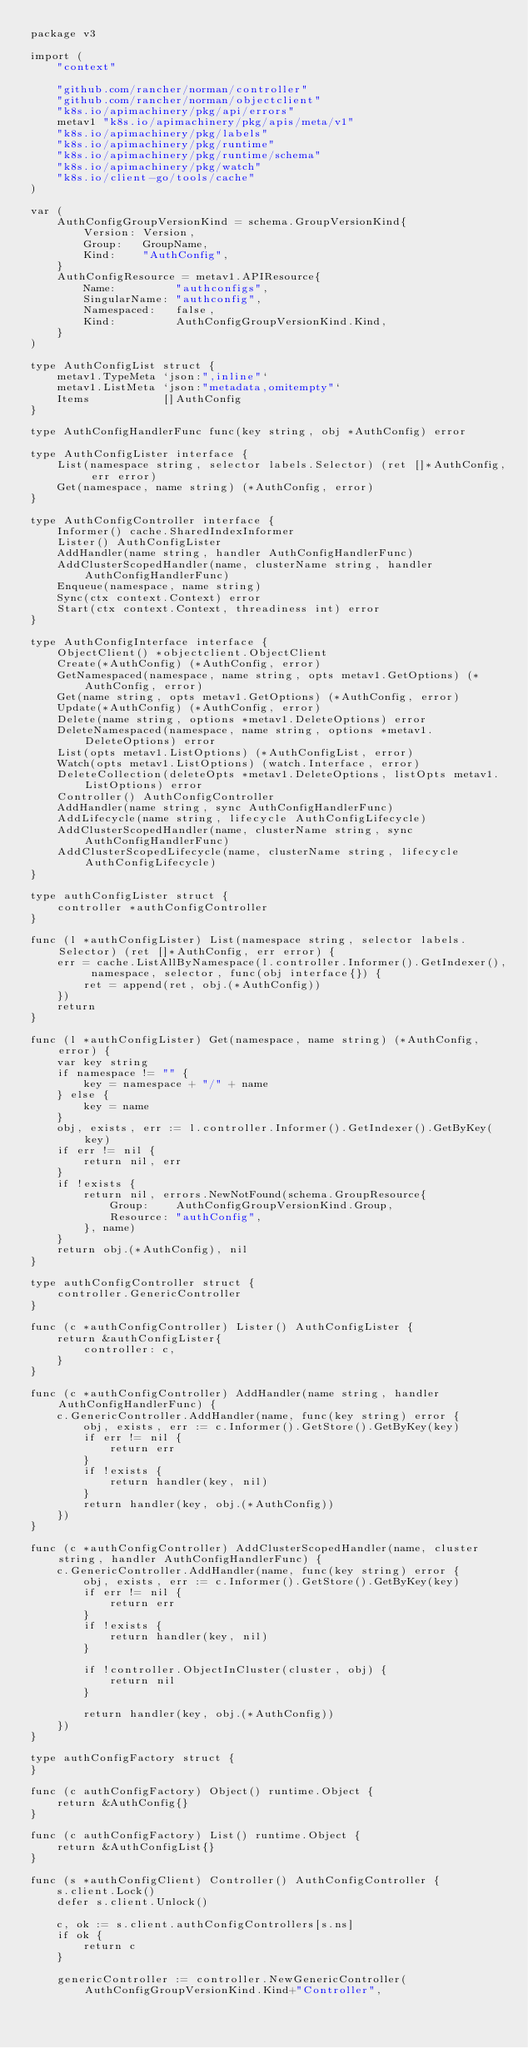Convert code to text. <code><loc_0><loc_0><loc_500><loc_500><_Go_>package v3

import (
	"context"

	"github.com/rancher/norman/controller"
	"github.com/rancher/norman/objectclient"
	"k8s.io/apimachinery/pkg/api/errors"
	metav1 "k8s.io/apimachinery/pkg/apis/meta/v1"
	"k8s.io/apimachinery/pkg/labels"
	"k8s.io/apimachinery/pkg/runtime"
	"k8s.io/apimachinery/pkg/runtime/schema"
	"k8s.io/apimachinery/pkg/watch"
	"k8s.io/client-go/tools/cache"
)

var (
	AuthConfigGroupVersionKind = schema.GroupVersionKind{
		Version: Version,
		Group:   GroupName,
		Kind:    "AuthConfig",
	}
	AuthConfigResource = metav1.APIResource{
		Name:         "authconfigs",
		SingularName: "authconfig",
		Namespaced:   false,
		Kind:         AuthConfigGroupVersionKind.Kind,
	}
)

type AuthConfigList struct {
	metav1.TypeMeta `json:",inline"`
	metav1.ListMeta `json:"metadata,omitempty"`
	Items           []AuthConfig
}

type AuthConfigHandlerFunc func(key string, obj *AuthConfig) error

type AuthConfigLister interface {
	List(namespace string, selector labels.Selector) (ret []*AuthConfig, err error)
	Get(namespace, name string) (*AuthConfig, error)
}

type AuthConfigController interface {
	Informer() cache.SharedIndexInformer
	Lister() AuthConfigLister
	AddHandler(name string, handler AuthConfigHandlerFunc)
	AddClusterScopedHandler(name, clusterName string, handler AuthConfigHandlerFunc)
	Enqueue(namespace, name string)
	Sync(ctx context.Context) error
	Start(ctx context.Context, threadiness int) error
}

type AuthConfigInterface interface {
	ObjectClient() *objectclient.ObjectClient
	Create(*AuthConfig) (*AuthConfig, error)
	GetNamespaced(namespace, name string, opts metav1.GetOptions) (*AuthConfig, error)
	Get(name string, opts metav1.GetOptions) (*AuthConfig, error)
	Update(*AuthConfig) (*AuthConfig, error)
	Delete(name string, options *metav1.DeleteOptions) error
	DeleteNamespaced(namespace, name string, options *metav1.DeleteOptions) error
	List(opts metav1.ListOptions) (*AuthConfigList, error)
	Watch(opts metav1.ListOptions) (watch.Interface, error)
	DeleteCollection(deleteOpts *metav1.DeleteOptions, listOpts metav1.ListOptions) error
	Controller() AuthConfigController
	AddHandler(name string, sync AuthConfigHandlerFunc)
	AddLifecycle(name string, lifecycle AuthConfigLifecycle)
	AddClusterScopedHandler(name, clusterName string, sync AuthConfigHandlerFunc)
	AddClusterScopedLifecycle(name, clusterName string, lifecycle AuthConfigLifecycle)
}

type authConfigLister struct {
	controller *authConfigController
}

func (l *authConfigLister) List(namespace string, selector labels.Selector) (ret []*AuthConfig, err error) {
	err = cache.ListAllByNamespace(l.controller.Informer().GetIndexer(), namespace, selector, func(obj interface{}) {
		ret = append(ret, obj.(*AuthConfig))
	})
	return
}

func (l *authConfigLister) Get(namespace, name string) (*AuthConfig, error) {
	var key string
	if namespace != "" {
		key = namespace + "/" + name
	} else {
		key = name
	}
	obj, exists, err := l.controller.Informer().GetIndexer().GetByKey(key)
	if err != nil {
		return nil, err
	}
	if !exists {
		return nil, errors.NewNotFound(schema.GroupResource{
			Group:    AuthConfigGroupVersionKind.Group,
			Resource: "authConfig",
		}, name)
	}
	return obj.(*AuthConfig), nil
}

type authConfigController struct {
	controller.GenericController
}

func (c *authConfigController) Lister() AuthConfigLister {
	return &authConfigLister{
		controller: c,
	}
}

func (c *authConfigController) AddHandler(name string, handler AuthConfigHandlerFunc) {
	c.GenericController.AddHandler(name, func(key string) error {
		obj, exists, err := c.Informer().GetStore().GetByKey(key)
		if err != nil {
			return err
		}
		if !exists {
			return handler(key, nil)
		}
		return handler(key, obj.(*AuthConfig))
	})
}

func (c *authConfigController) AddClusterScopedHandler(name, cluster string, handler AuthConfigHandlerFunc) {
	c.GenericController.AddHandler(name, func(key string) error {
		obj, exists, err := c.Informer().GetStore().GetByKey(key)
		if err != nil {
			return err
		}
		if !exists {
			return handler(key, nil)
		}

		if !controller.ObjectInCluster(cluster, obj) {
			return nil
		}

		return handler(key, obj.(*AuthConfig))
	})
}

type authConfigFactory struct {
}

func (c authConfigFactory) Object() runtime.Object {
	return &AuthConfig{}
}

func (c authConfigFactory) List() runtime.Object {
	return &AuthConfigList{}
}

func (s *authConfigClient) Controller() AuthConfigController {
	s.client.Lock()
	defer s.client.Unlock()

	c, ok := s.client.authConfigControllers[s.ns]
	if ok {
		return c
	}

	genericController := controller.NewGenericController(AuthConfigGroupVersionKind.Kind+"Controller",</code> 